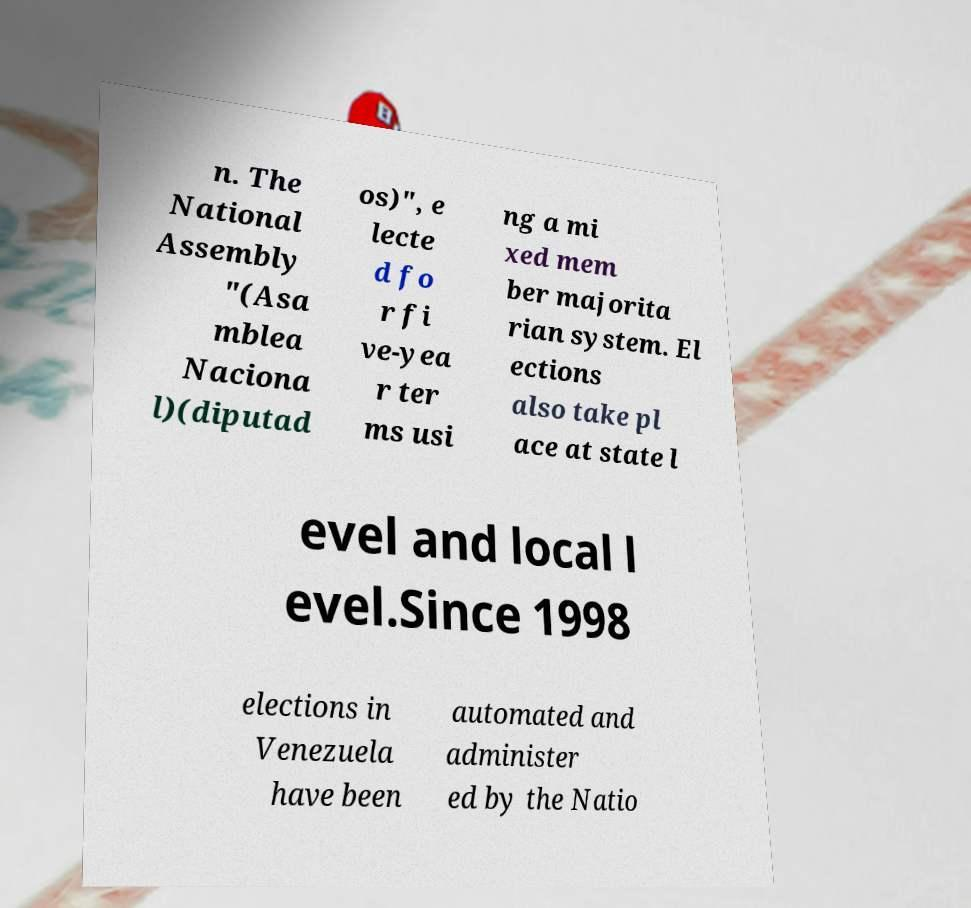For documentation purposes, I need the text within this image transcribed. Could you provide that? n. The National Assembly "(Asa mblea Naciona l)(diputad os)", e lecte d fo r fi ve-yea r ter ms usi ng a mi xed mem ber majorita rian system. El ections also take pl ace at state l evel and local l evel.Since 1998 elections in Venezuela have been automated and administer ed by the Natio 